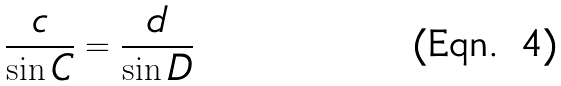Convert formula to latex. <formula><loc_0><loc_0><loc_500><loc_500>\frac { c } { \sin C } = \frac { d } { \sin D }</formula> 